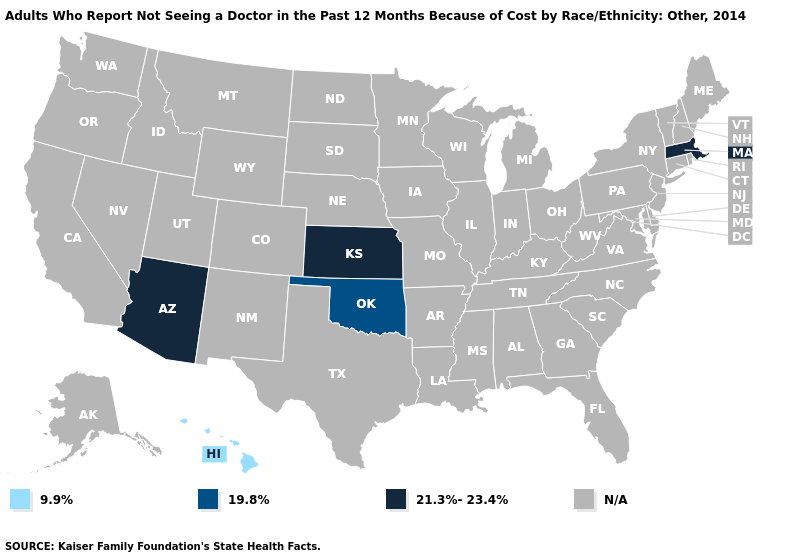What is the highest value in the Northeast ?
Answer briefly. 21.3%-23.4%. Name the states that have a value in the range 19.8%?
Short answer required. Oklahoma. Which states have the highest value in the USA?
Concise answer only. Arizona, Kansas, Massachusetts. Name the states that have a value in the range 9.9%?
Give a very brief answer. Hawaii. Which states hav the highest value in the MidWest?
Quick response, please. Kansas. Which states have the lowest value in the USA?
Answer briefly. Hawaii. Which states hav the highest value in the Northeast?
Give a very brief answer. Massachusetts. Name the states that have a value in the range 19.8%?
Keep it brief. Oklahoma. Name the states that have a value in the range 21.3%-23.4%?
Write a very short answer. Arizona, Kansas, Massachusetts. What is the lowest value in the USA?
Give a very brief answer. 9.9%. What is the value of Indiana?
Answer briefly. N/A. Which states have the lowest value in the USA?
Quick response, please. Hawaii. What is the lowest value in the West?
Short answer required. 9.9%. Which states have the lowest value in the USA?
Write a very short answer. Hawaii. How many symbols are there in the legend?
Keep it brief. 4. 